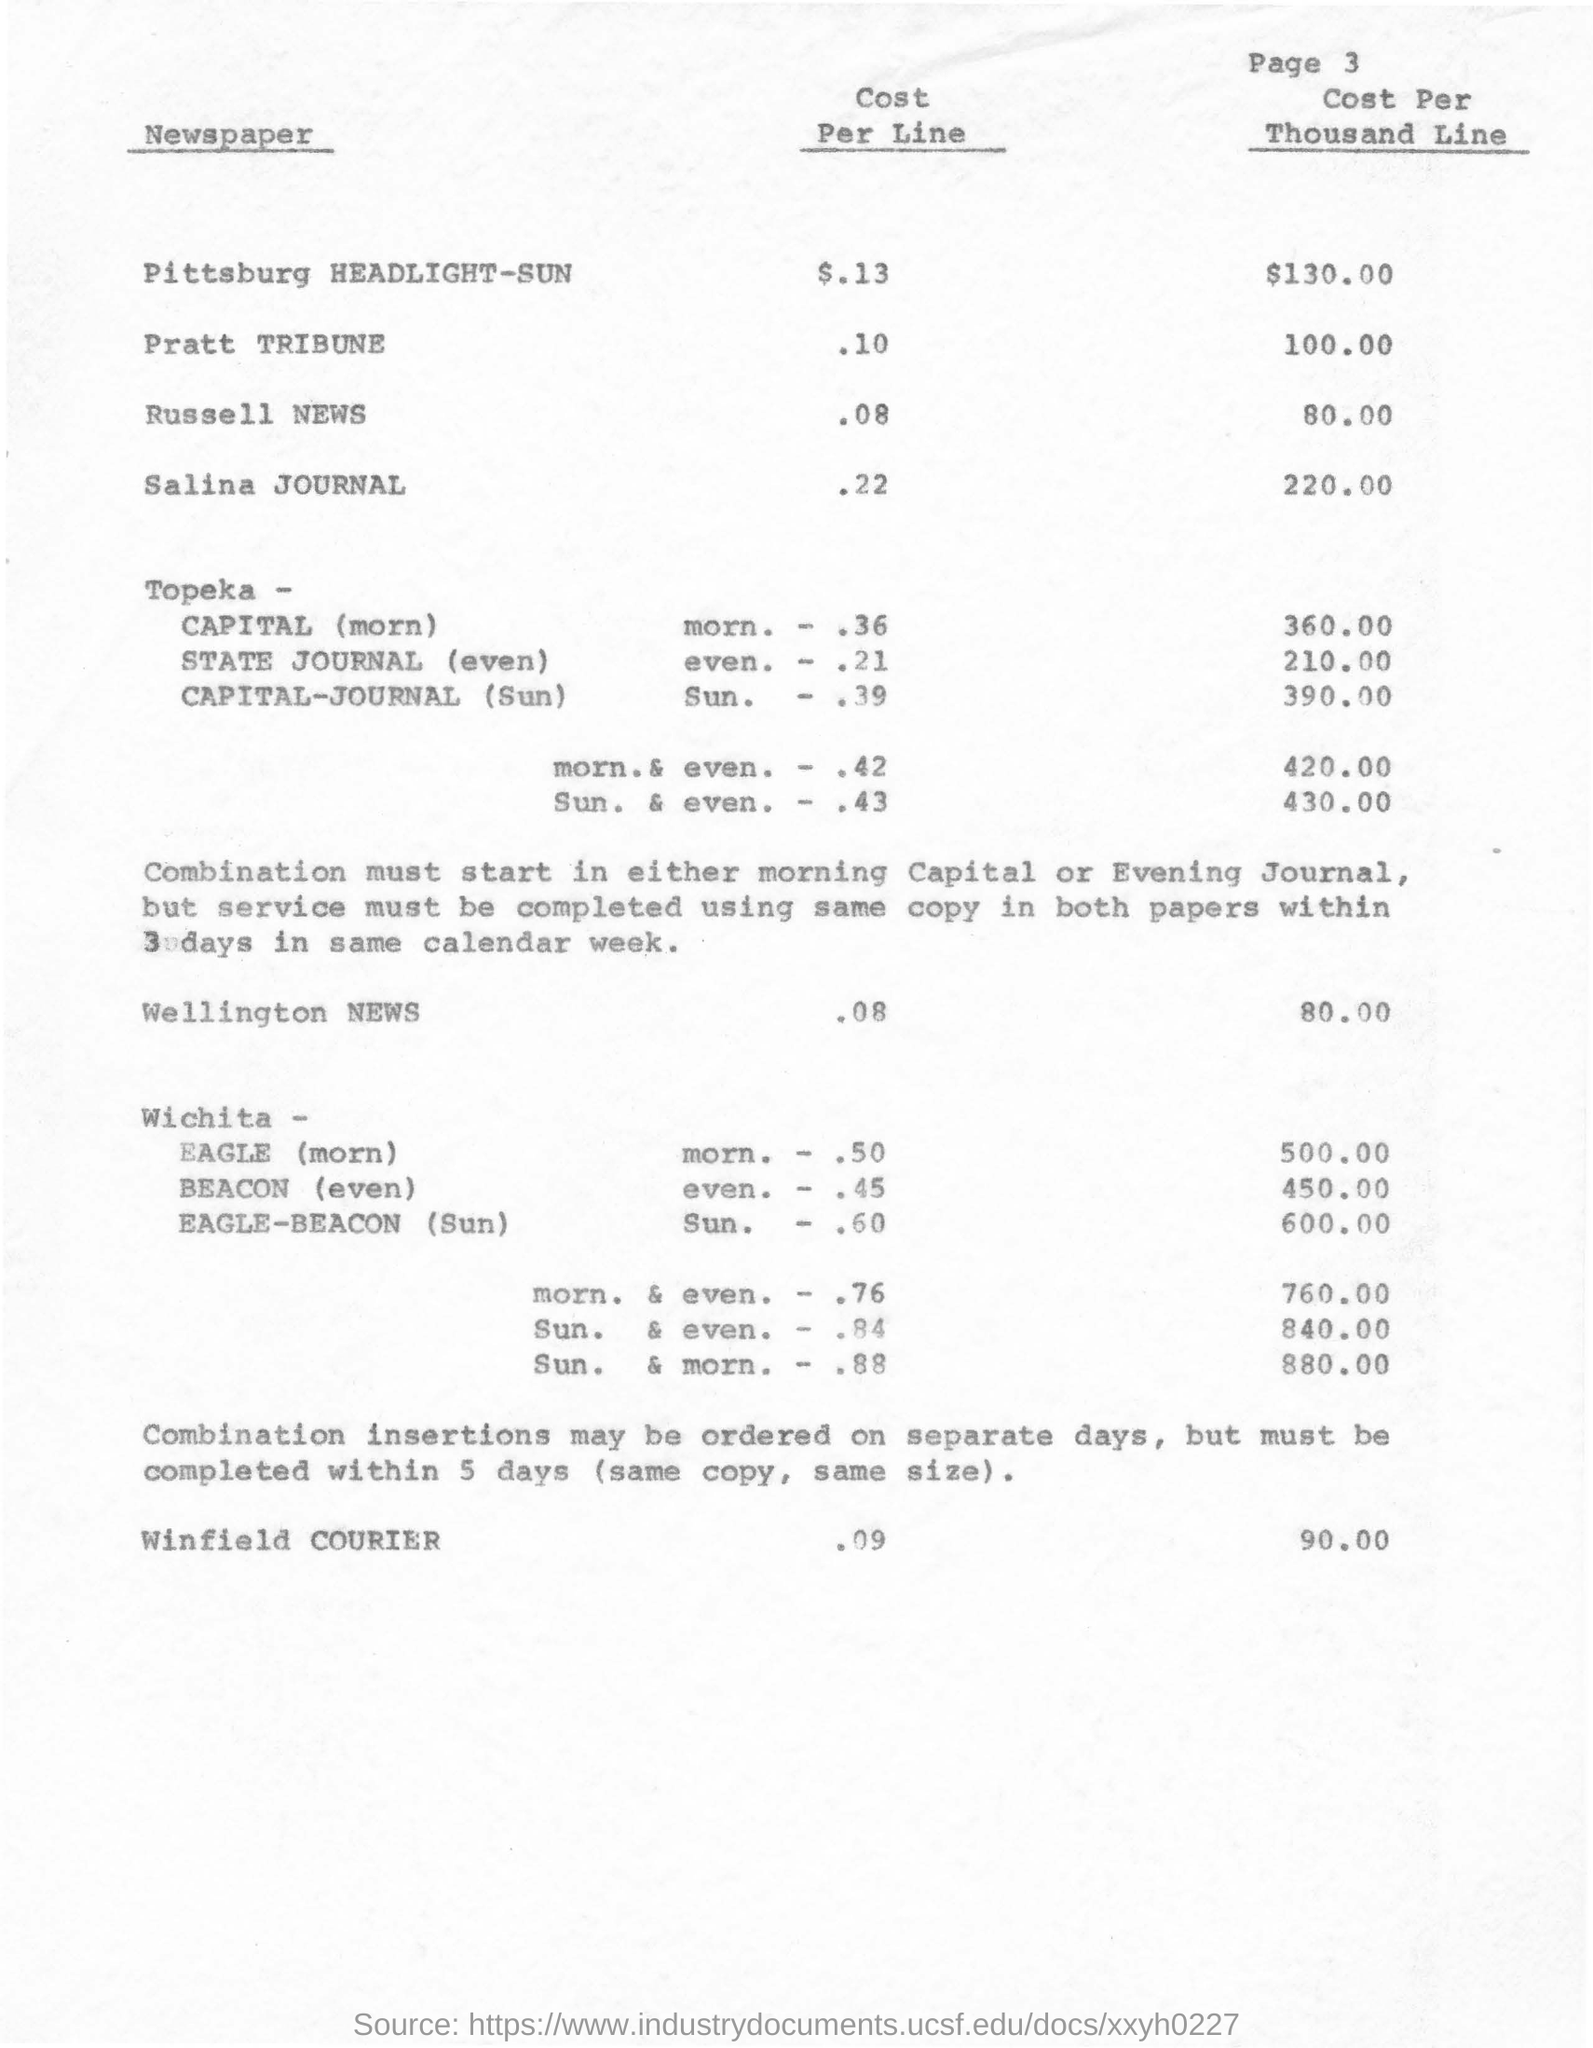Point out several critical features in this image. The page number mentioned in this document is 3. Winfield COURIER offers a cost per line of $0.09. The cost per thousand lines for the Pittsburgh HEADLIGHT-SUN newspaper is $130.00. The cost per line for the Pratt Tribune newspaper is ten cents. 